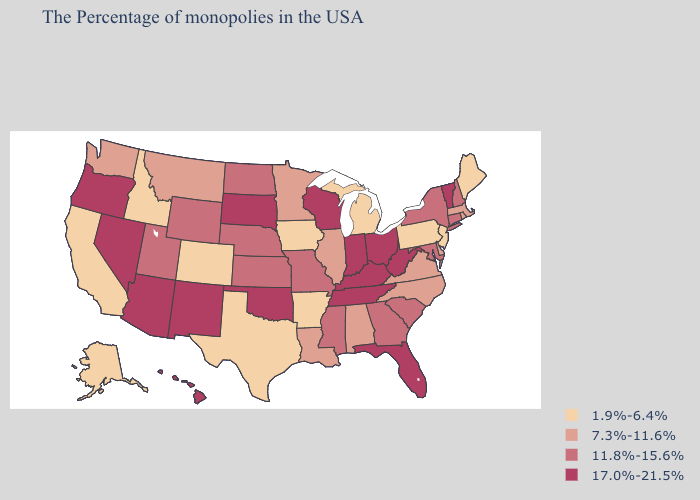Does the map have missing data?
Keep it brief. No. What is the lowest value in states that border Idaho?
Answer briefly. 7.3%-11.6%. Does Texas have the lowest value in the USA?
Give a very brief answer. Yes. Name the states that have a value in the range 1.9%-6.4%?
Write a very short answer. Maine, New Jersey, Pennsylvania, Michigan, Arkansas, Iowa, Texas, Colorado, Idaho, California, Alaska. Name the states that have a value in the range 11.8%-15.6%?
Give a very brief answer. New Hampshire, Connecticut, New York, Maryland, South Carolina, Georgia, Mississippi, Missouri, Kansas, Nebraska, North Dakota, Wyoming, Utah. Name the states that have a value in the range 1.9%-6.4%?
Write a very short answer. Maine, New Jersey, Pennsylvania, Michigan, Arkansas, Iowa, Texas, Colorado, Idaho, California, Alaska. Which states have the highest value in the USA?
Concise answer only. Vermont, West Virginia, Ohio, Florida, Kentucky, Indiana, Tennessee, Wisconsin, Oklahoma, South Dakota, New Mexico, Arizona, Nevada, Oregon, Hawaii. Which states have the highest value in the USA?
Keep it brief. Vermont, West Virginia, Ohio, Florida, Kentucky, Indiana, Tennessee, Wisconsin, Oklahoma, South Dakota, New Mexico, Arizona, Nevada, Oregon, Hawaii. Name the states that have a value in the range 1.9%-6.4%?
Keep it brief. Maine, New Jersey, Pennsylvania, Michigan, Arkansas, Iowa, Texas, Colorado, Idaho, California, Alaska. Does New York have a higher value than Wyoming?
Write a very short answer. No. What is the highest value in the USA?
Concise answer only. 17.0%-21.5%. Among the states that border New Hampshire , does Massachusetts have the highest value?
Be succinct. No. Which states have the highest value in the USA?
Write a very short answer. Vermont, West Virginia, Ohio, Florida, Kentucky, Indiana, Tennessee, Wisconsin, Oklahoma, South Dakota, New Mexico, Arizona, Nevada, Oregon, Hawaii. Name the states that have a value in the range 17.0%-21.5%?
Keep it brief. Vermont, West Virginia, Ohio, Florida, Kentucky, Indiana, Tennessee, Wisconsin, Oklahoma, South Dakota, New Mexico, Arizona, Nevada, Oregon, Hawaii. 